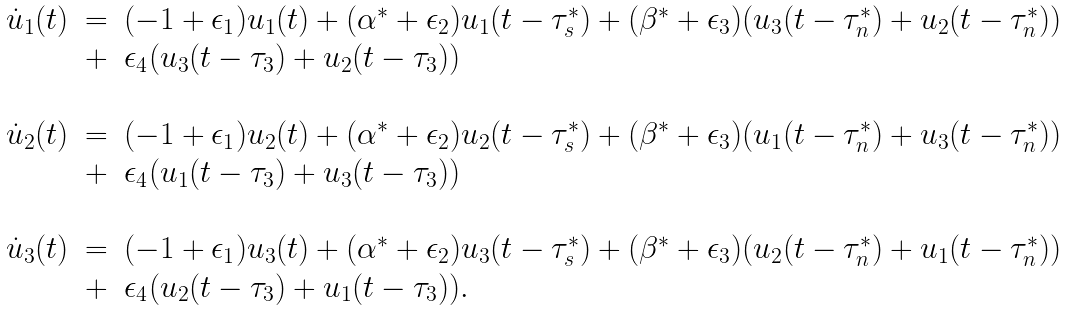<formula> <loc_0><loc_0><loc_500><loc_500>\begin{array} { r c l } \dot { u } _ { 1 } ( t ) & = & ( - 1 + \epsilon _ { 1 } ) u _ { 1 } ( t ) + ( \alpha ^ { * } + \epsilon _ { 2 } ) u _ { 1 } ( t - \tau _ { s } ^ { * } ) + ( \beta ^ { * } + \epsilon _ { 3 } ) ( u _ { 3 } ( t - \tau _ { n } ^ { * } ) + u _ { 2 } ( t - \tau _ { n } ^ { * } ) ) \\ & + & \epsilon _ { 4 } ( u _ { 3 } ( t - \tau _ { 3 } ) + u _ { 2 } ( t - \tau _ { 3 } ) ) \\ \\ \dot { u } _ { 2 } ( t ) & = & ( - 1 + \epsilon _ { 1 } ) u _ { 2 } ( t ) + ( \alpha ^ { * } + \epsilon _ { 2 } ) u _ { 2 } ( t - \tau _ { s } ^ { * } ) + ( \beta ^ { * } + \epsilon _ { 3 } ) ( u _ { 1 } ( t - \tau _ { n } ^ { * } ) + u _ { 3 } ( t - \tau _ { n } ^ { * } ) ) \\ & + & \epsilon _ { 4 } ( u _ { 1 } ( t - \tau _ { 3 } ) + u _ { 3 } ( t - \tau _ { 3 } ) ) \\ \\ \dot { u } _ { 3 } ( t ) & = & ( - 1 + \epsilon _ { 1 } ) u _ { 3 } ( t ) + ( \alpha ^ { * } + \epsilon _ { 2 } ) u _ { 3 } ( t - \tau _ { s } ^ { * } ) + ( \beta ^ { * } + \epsilon _ { 3 } ) ( u _ { 2 } ( t - \tau _ { n } ^ { * } ) + u _ { 1 } ( t - \tau _ { n } ^ { * } ) ) \\ & + & \epsilon _ { 4 } ( u _ { 2 } ( t - \tau _ { 3 } ) + u _ { 1 } ( t - \tau _ { 3 } ) ) . \end{array}</formula> 